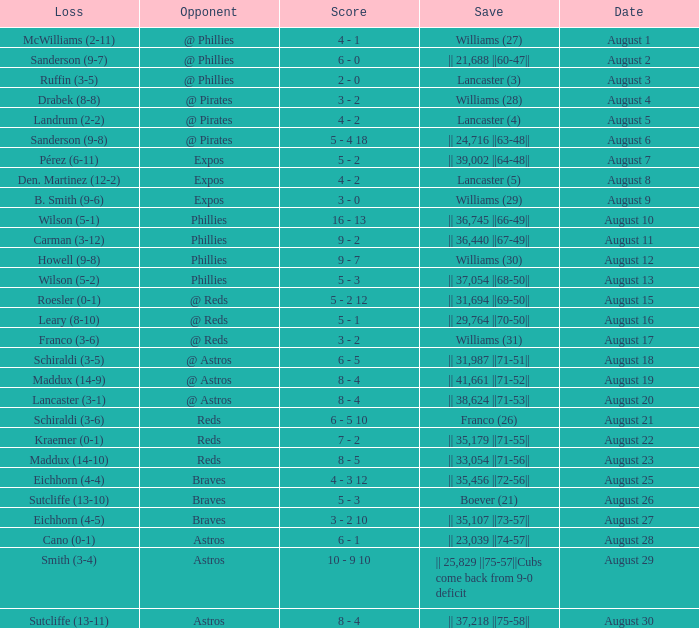Name the opponent with loss of sanderson (9-8) @ Pirates. 